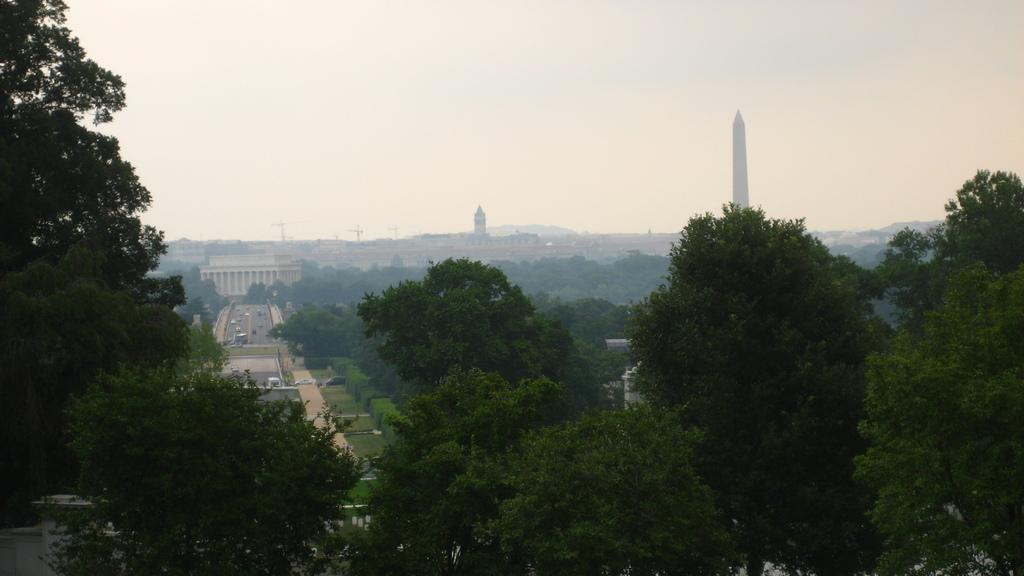What type of natural elements can be seen in the image? There are trees in the image. What type of man-made structure is visible in the background? There is a road in the background of the image. What is moving along the road in the image? There are vehicles on the road. What type of buildings can be seen in the image? There are buildings in the image. What tall structures are present in the image? There are towers in the image. What part of the natural environment is visible in the image? The sky is visible in the image. What type of polish is being applied to the card in the image? There is no card or polish present in the image. What is the pencil being used for in the image? There is no pencil present in the image. 